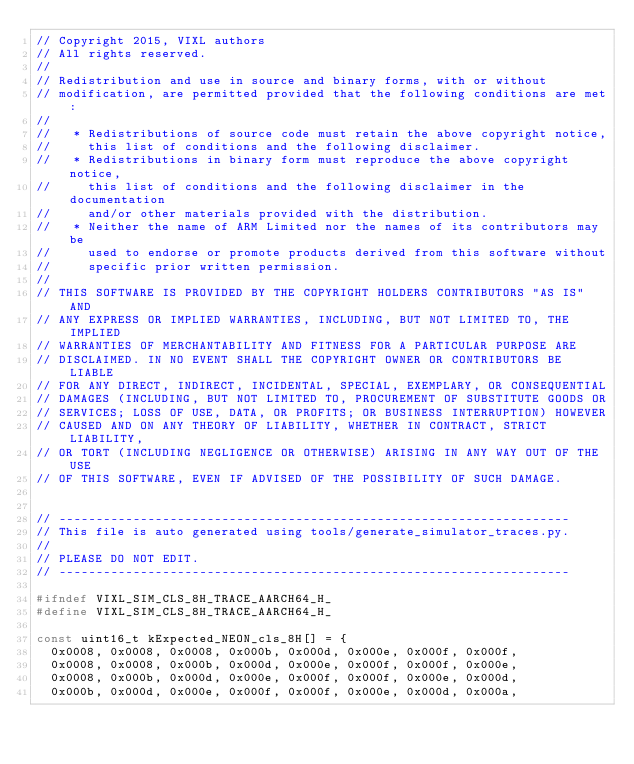<code> <loc_0><loc_0><loc_500><loc_500><_C_>// Copyright 2015, VIXL authors
// All rights reserved.
//
// Redistribution and use in source and binary forms, with or without
// modification, are permitted provided that the following conditions are met:
//
//   * Redistributions of source code must retain the above copyright notice,
//     this list of conditions and the following disclaimer.
//   * Redistributions in binary form must reproduce the above copyright notice,
//     this list of conditions and the following disclaimer in the documentation
//     and/or other materials provided with the distribution.
//   * Neither the name of ARM Limited nor the names of its contributors may be
//     used to endorse or promote products derived from this software without
//     specific prior written permission.
//
// THIS SOFTWARE IS PROVIDED BY THE COPYRIGHT HOLDERS CONTRIBUTORS "AS IS" AND
// ANY EXPRESS OR IMPLIED WARRANTIES, INCLUDING, BUT NOT LIMITED TO, THE IMPLIED
// WARRANTIES OF MERCHANTABILITY AND FITNESS FOR A PARTICULAR PURPOSE ARE
// DISCLAIMED. IN NO EVENT SHALL THE COPYRIGHT OWNER OR CONTRIBUTORS BE LIABLE
// FOR ANY DIRECT, INDIRECT, INCIDENTAL, SPECIAL, EXEMPLARY, OR CONSEQUENTIAL
// DAMAGES (INCLUDING, BUT NOT LIMITED TO, PROCUREMENT OF SUBSTITUTE GOODS OR
// SERVICES; LOSS OF USE, DATA, OR PROFITS; OR BUSINESS INTERRUPTION) HOWEVER
// CAUSED AND ON ANY THEORY OF LIABILITY, WHETHER IN CONTRACT, STRICT LIABILITY,
// OR TORT (INCLUDING NEGLIGENCE OR OTHERWISE) ARISING IN ANY WAY OUT OF THE USE
// OF THIS SOFTWARE, EVEN IF ADVISED OF THE POSSIBILITY OF SUCH DAMAGE.


// ---------------------------------------------------------------------
// This file is auto generated using tools/generate_simulator_traces.py.
//
// PLEASE DO NOT EDIT.
// ---------------------------------------------------------------------

#ifndef VIXL_SIM_CLS_8H_TRACE_AARCH64_H_
#define VIXL_SIM_CLS_8H_TRACE_AARCH64_H_

const uint16_t kExpected_NEON_cls_8H[] = {
  0x0008, 0x0008, 0x0008, 0x000b, 0x000d, 0x000e, 0x000f, 0x000f,
  0x0008, 0x0008, 0x000b, 0x000d, 0x000e, 0x000f, 0x000f, 0x000e,
  0x0008, 0x000b, 0x000d, 0x000e, 0x000f, 0x000f, 0x000e, 0x000d,
  0x000b, 0x000d, 0x000e, 0x000f, 0x000f, 0x000e, 0x000d, 0x000a,</code> 